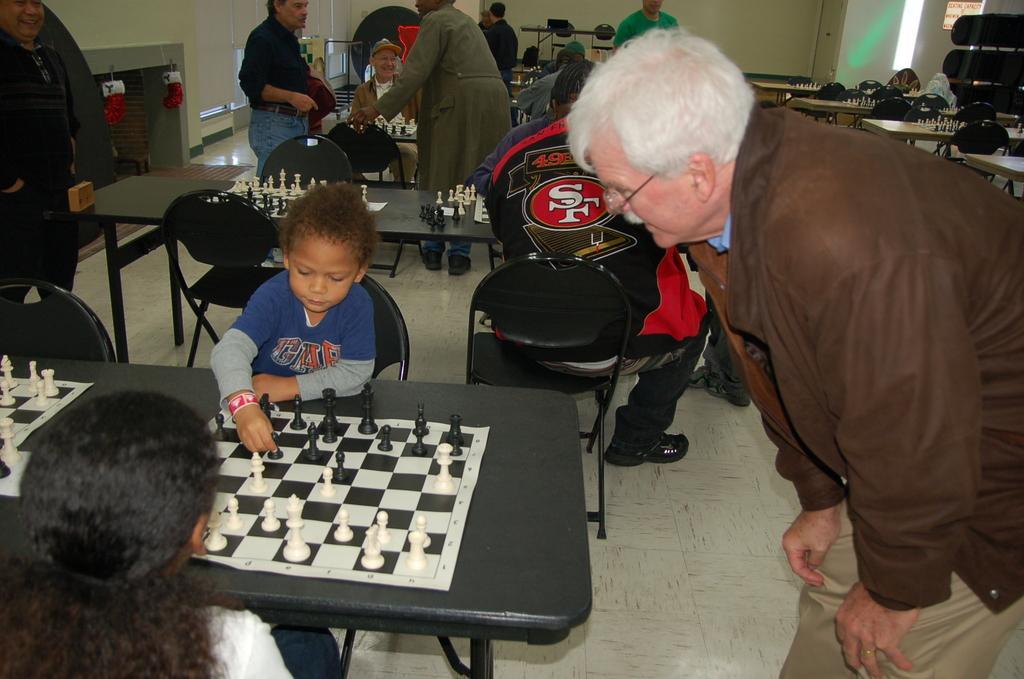Please provide a concise description of this image. This kid is sitting on a chair and playing this chess. Some persons are sitting on chairs and few persons are standing. In-front of them there are tables, on this tables there are chess board and coins. This man wore brown jacket and looking at this kid. 